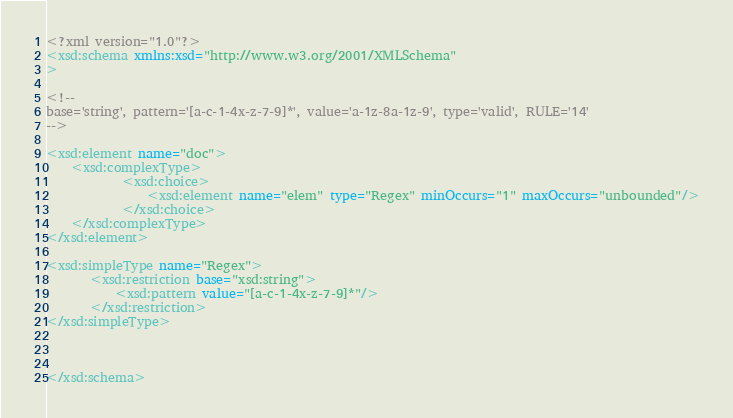<code> <loc_0><loc_0><loc_500><loc_500><_XML_><?xml version="1.0"?>
<xsd:schema xmlns:xsd="http://www.w3.org/2001/XMLSchema"
>

<!-- 
base='string', pattern='[a-c-1-4x-z-7-9]*', value='a-1z-8a-1z-9', type='valid', RULE='14'
-->

<xsd:element name="doc">
    <xsd:complexType>
            <xsd:choice>
                <xsd:element name="elem" type="Regex" minOccurs="1" maxOccurs="unbounded"/>
            </xsd:choice>
    </xsd:complexType>
</xsd:element>

<xsd:simpleType name="Regex">
       <xsd:restriction base="xsd:string">
           <xsd:pattern value="[a-c-1-4x-z-7-9]*"/>    
       </xsd:restriction>
</xsd:simpleType>



</xsd:schema>
</code> 